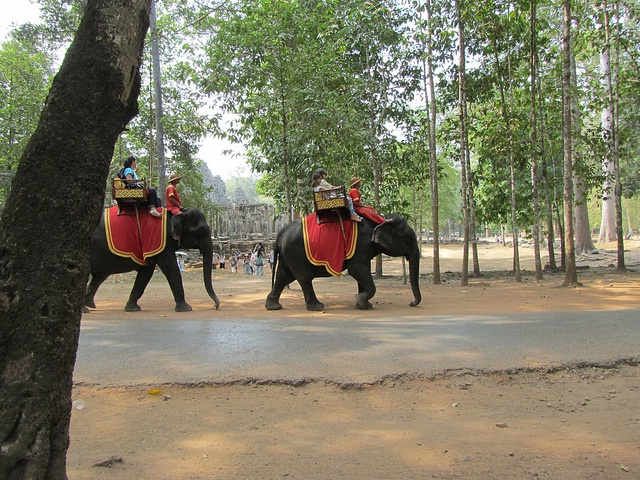Describe the objects in this image and their specific colors. I can see elephant in white, black, brown, maroon, and gray tones, elephant in white, black, maroon, brown, and tan tones, bench in white, black, maroon, and olive tones, bench in white, black, gray, and olive tones, and people in white, black, gray, and darkgray tones in this image. 